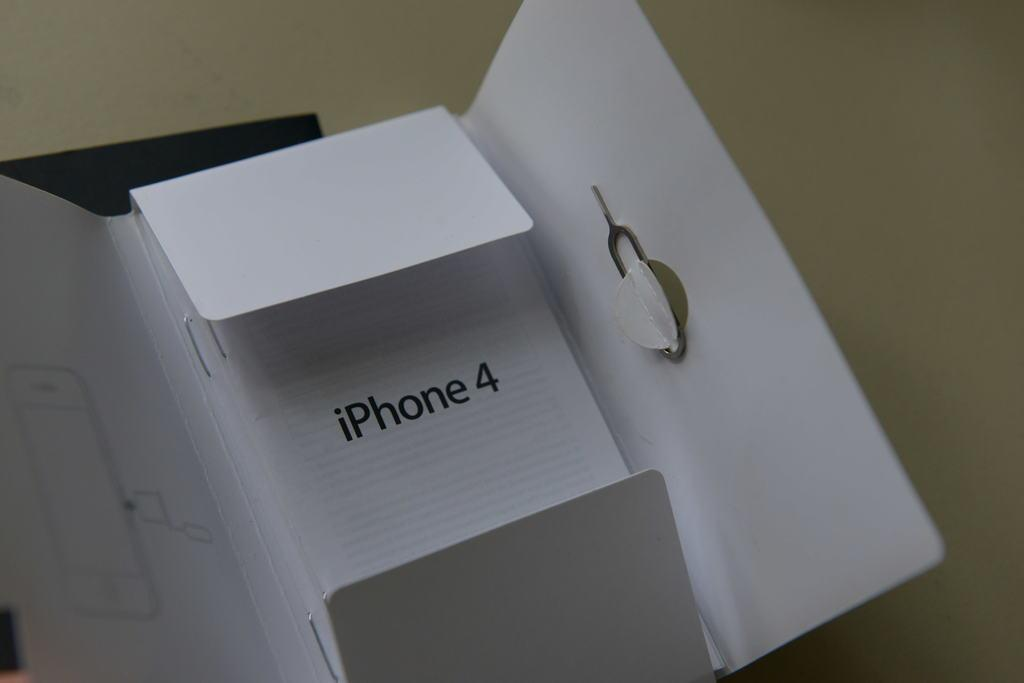<image>
Summarize the visual content of the image. White packaging indicates that it once contained an iPhone 4. 